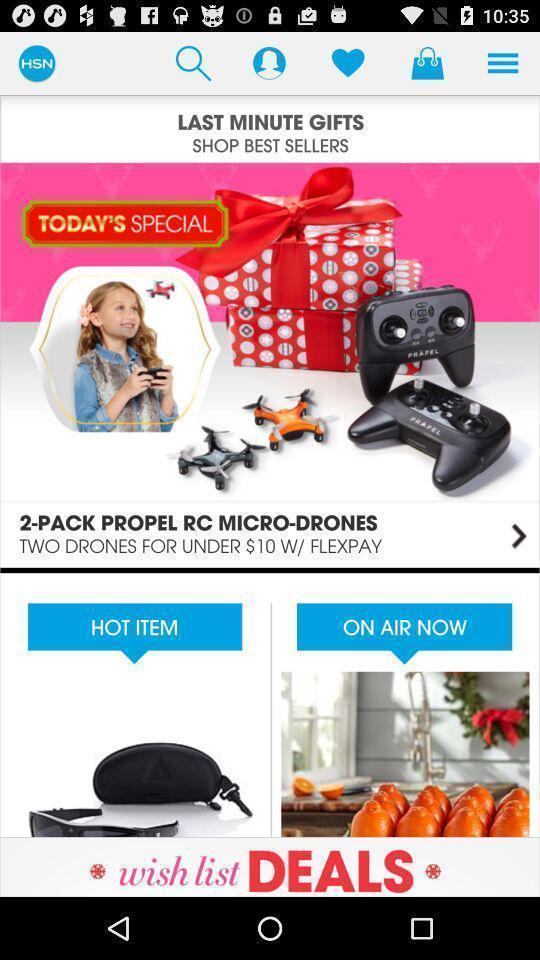Summarize the information in this screenshot. Screen displaying multiple options in a shopping application. 